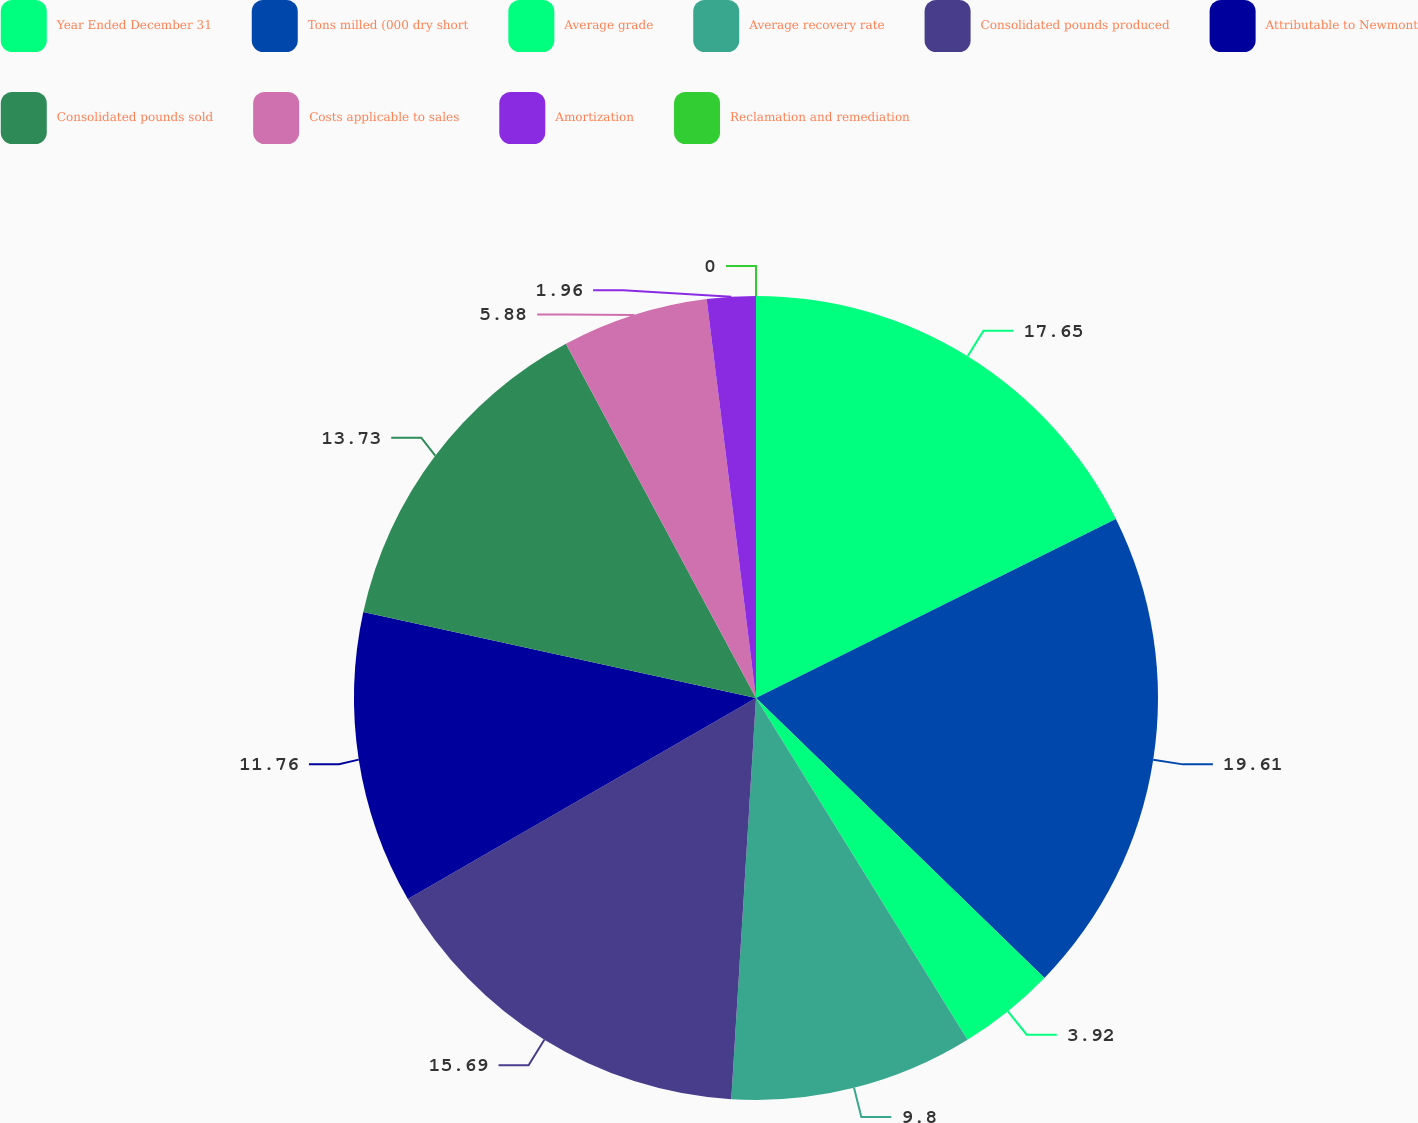Convert chart to OTSL. <chart><loc_0><loc_0><loc_500><loc_500><pie_chart><fcel>Year Ended December 31<fcel>Tons milled (000 dry short<fcel>Average grade<fcel>Average recovery rate<fcel>Consolidated pounds produced<fcel>Attributable to Newmont<fcel>Consolidated pounds sold<fcel>Costs applicable to sales<fcel>Amortization<fcel>Reclamation and remediation<nl><fcel>17.65%<fcel>19.61%<fcel>3.92%<fcel>9.8%<fcel>15.69%<fcel>11.76%<fcel>13.73%<fcel>5.88%<fcel>1.96%<fcel>0.0%<nl></chart> 